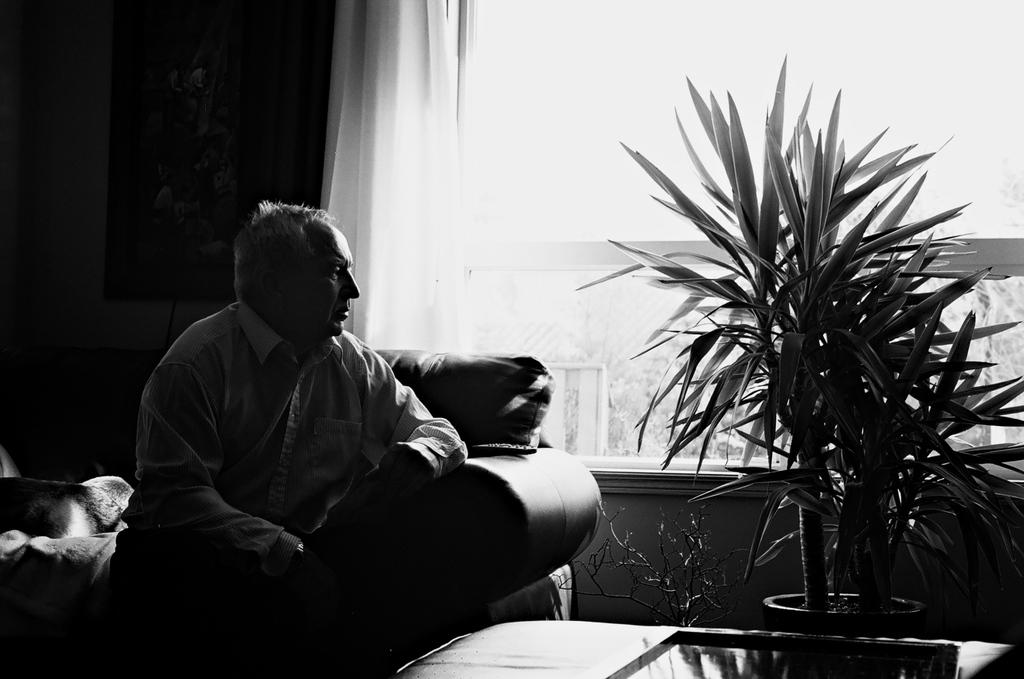What is the person in the image doing? The person is seated on the sofa. What can be seen beside the person? There is a plant beside the person. What is visible behind the person? There is a glass window behind the person. Is there any window treatment present in the image? Yes, there is a curtain on the glass window. What type of clock can be seen hanging on the curtain in the image? There is no clock visible in the image, and the curtain is not mentioned as having any objects hanging on it. 